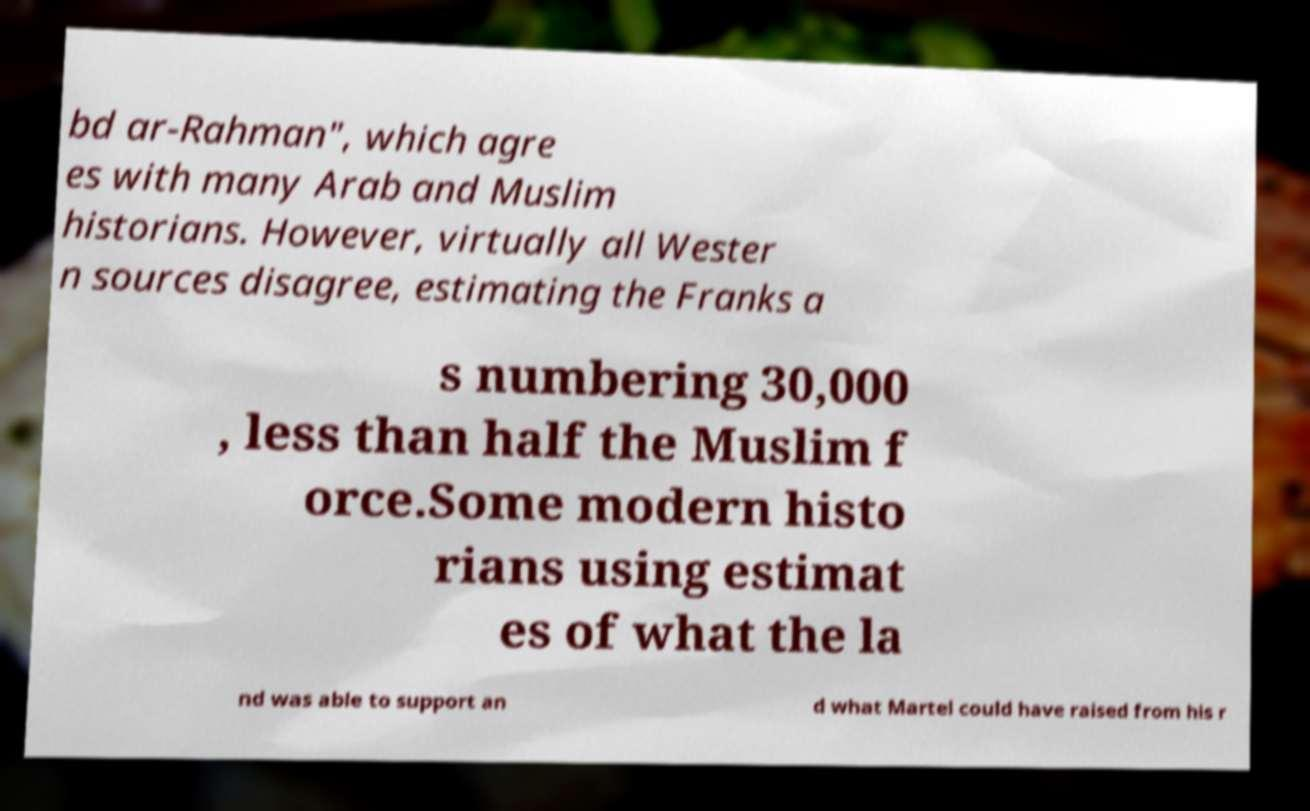Can you read and provide the text displayed in the image?This photo seems to have some interesting text. Can you extract and type it out for me? bd ar-Rahman", which agre es with many Arab and Muslim historians. However, virtually all Wester n sources disagree, estimating the Franks a s numbering 30,000 , less than half the Muslim f orce.Some modern histo rians using estimat es of what the la nd was able to support an d what Martel could have raised from his r 